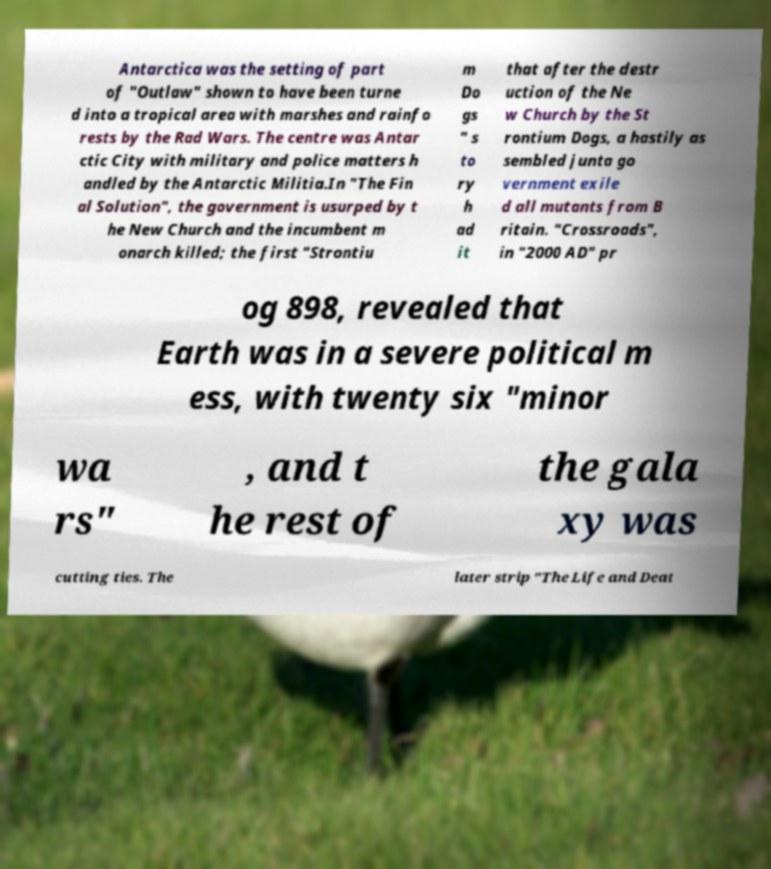I need the written content from this picture converted into text. Can you do that? Antarctica was the setting of part of "Outlaw" shown to have been turne d into a tropical area with marshes and rainfo rests by the Rad Wars. The centre was Antar ctic City with military and police matters h andled by the Antarctic Militia.In "The Fin al Solution", the government is usurped by t he New Church and the incumbent m onarch killed; the first "Strontiu m Do gs " s to ry h ad it that after the destr uction of the Ne w Church by the St rontium Dogs, a hastily as sembled junta go vernment exile d all mutants from B ritain. "Crossroads", in "2000 AD" pr og 898, revealed that Earth was in a severe political m ess, with twenty six "minor wa rs" , and t he rest of the gala xy was cutting ties. The later strip "The Life and Deat 